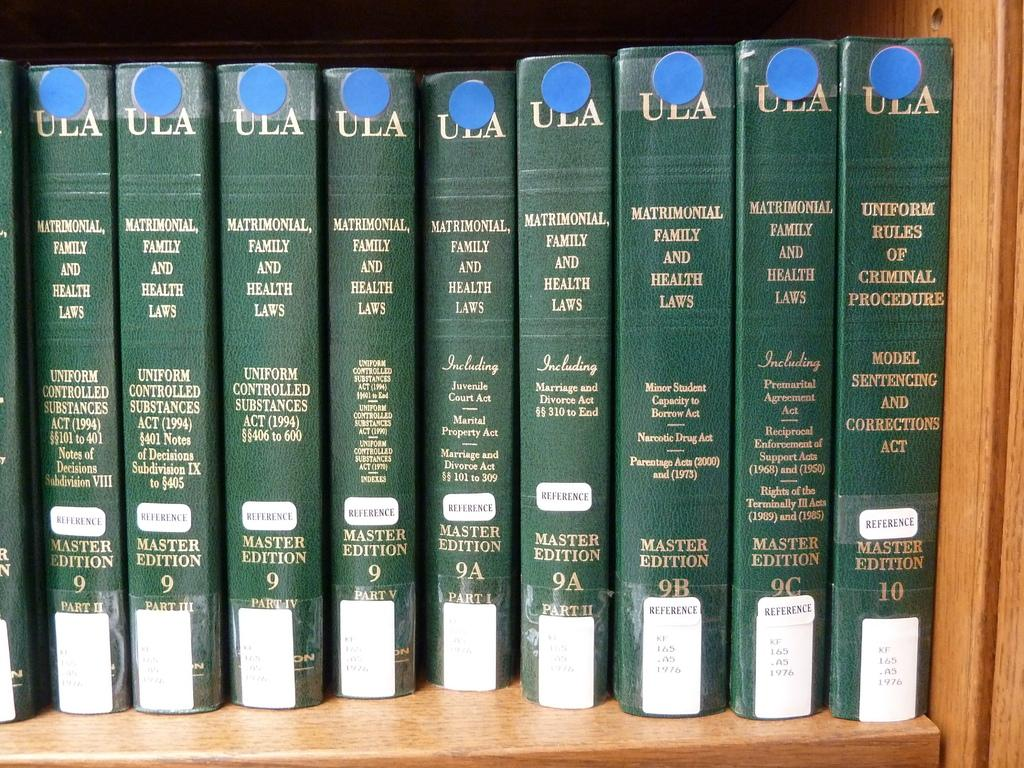<image>
Share a concise interpretation of the image provided. A collection of ULA reference books on what is likely a library shelf. 